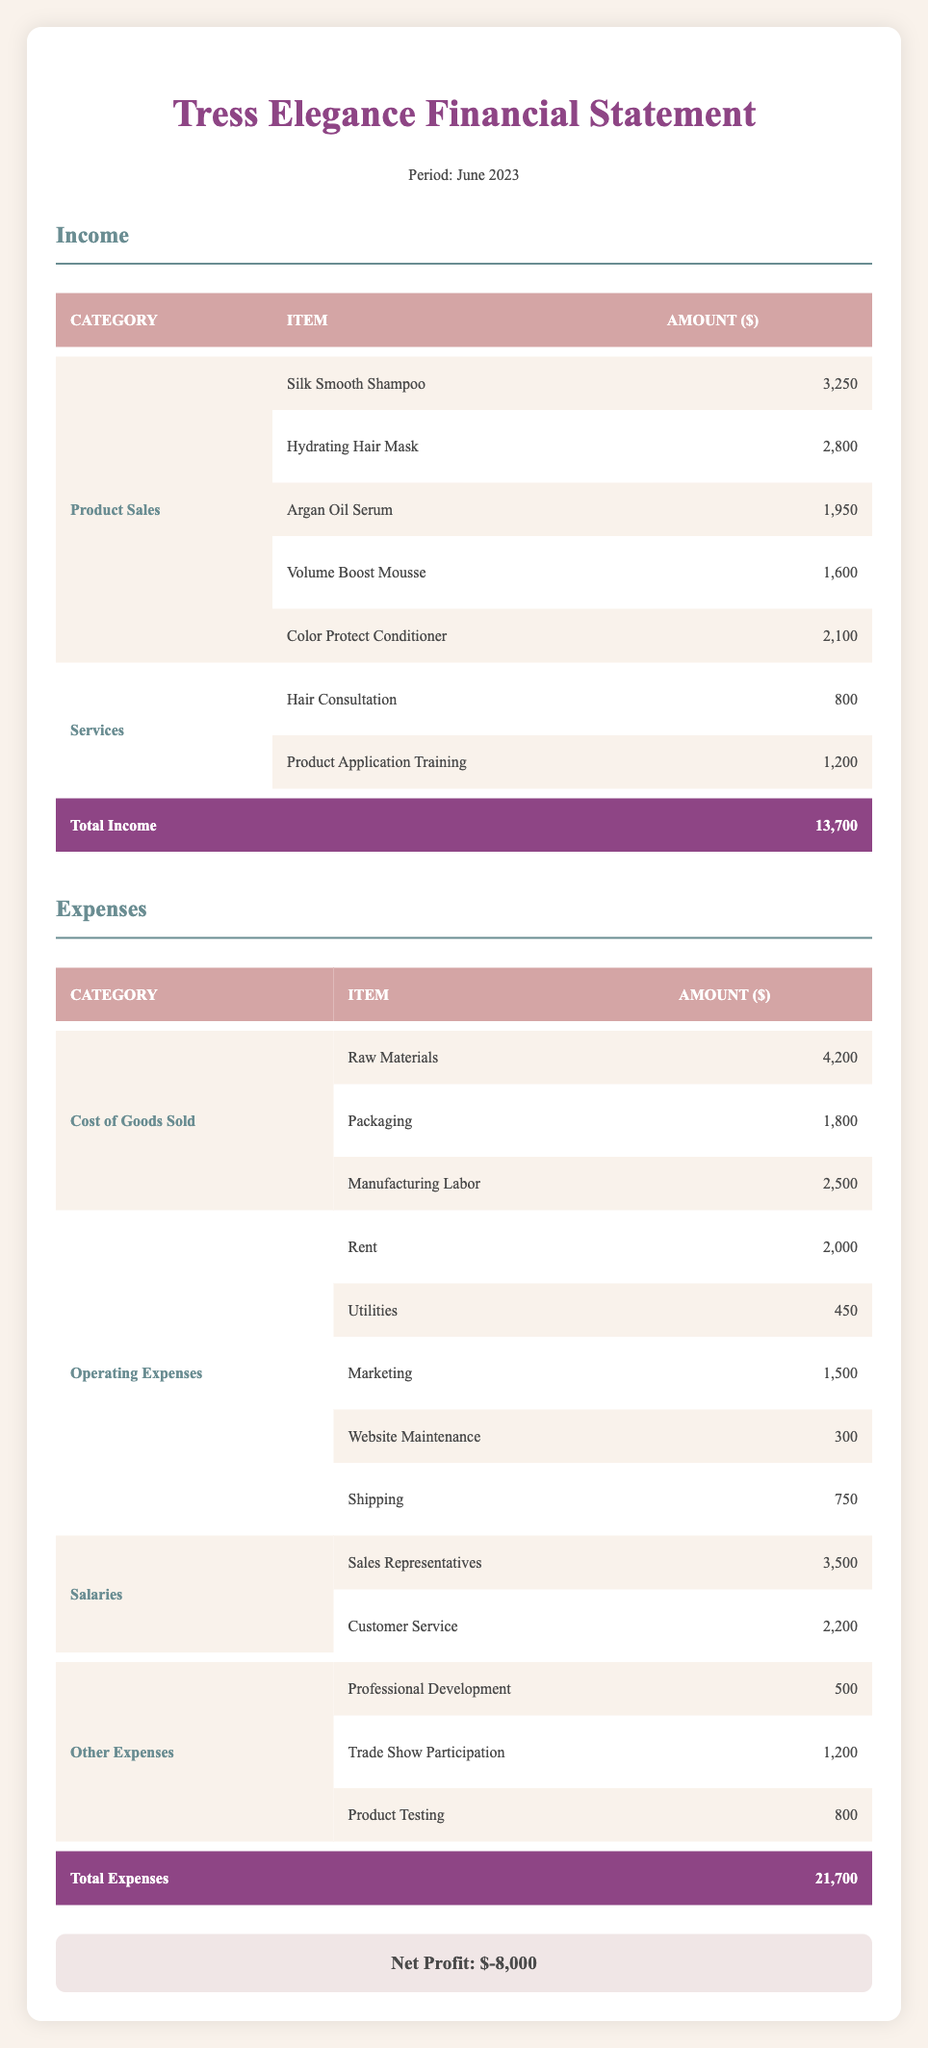What is the total income for June 2023? The total income is listed at the bottom of the income section of the table. It shows a total amount of 13,700 for June 2023.
Answer: 13,700 What is the highest selling product? By comparing the amounts listed under the Product Sales category, Silk Smooth Shampoo has the highest sales amount of 3,250.
Answer: Silk Smooth Shampoo What is the total amount spent on salaries? The total amount spent on salaries is obtained by summing the amounts for Sales Representatives and Customer Service, which are 3,500 and 2,200 respectively. This gives us a total of 3,500 + 2,200 = 5,700.
Answer: 5,700 Is the net profit positive or negative? The net profit is found at the bottom of the financial statement, which shows a net profit of -8,000. A negative value indicates a loss.
Answer: Negative What is the difference between total expenses and total income? To find the difference, subtract total income (13,700) from total expenses (21,700). The calculation is 21,700 - 13,700 = 8,000.
Answer: 8,000 How much was spent on marketing in June 2023? The marketing expenses can be found in the Operating Expenses category, showing an amount of 1,500 specifically allocated for marketing.
Answer: 1,500 What percentage of total income comes from product sales? To find the percentage, you take the total income from product sales (which is the sum of all product sales amounts: 3,250 + 2,800 + 1,950 + 1,600 + 2,100 = 11,700) and divide it by total income (13,700), then multiply by 100. So, (11,700 / 13,700) * 100 = 85.5%.
Answer: 85.5% What is the total amount spent on Operating Expenses? The amount can be calculated by summing the expenses in the Operating Expenses section: Rent (2,000) + Utilities (450) + Marketing (1,500) + Website Maintenance (300) + Shipping (750) = 5,000.
Answer: 5,000 Were 'Trade Show Participation' expenses higher than 'Product Application Training'? 'Trade Show Participation' shows an expense of 1,200, while 'Product Application Training' shows an income of 1,200. Since one is an expense and the other is income, the statement is not valid.
Answer: No 